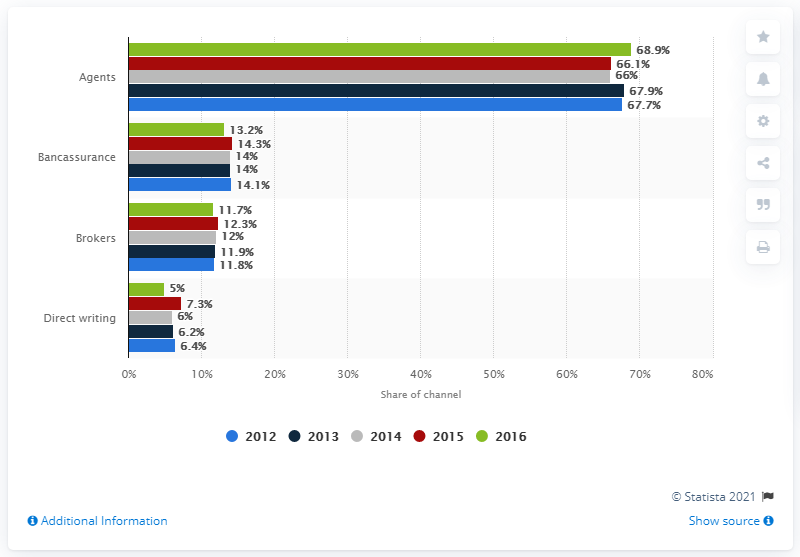Mention a couple of crucial points in this snapshot. From 2012 to 2016, the market share of non-life premiums distribution channels in Turkey was 68.9%. 